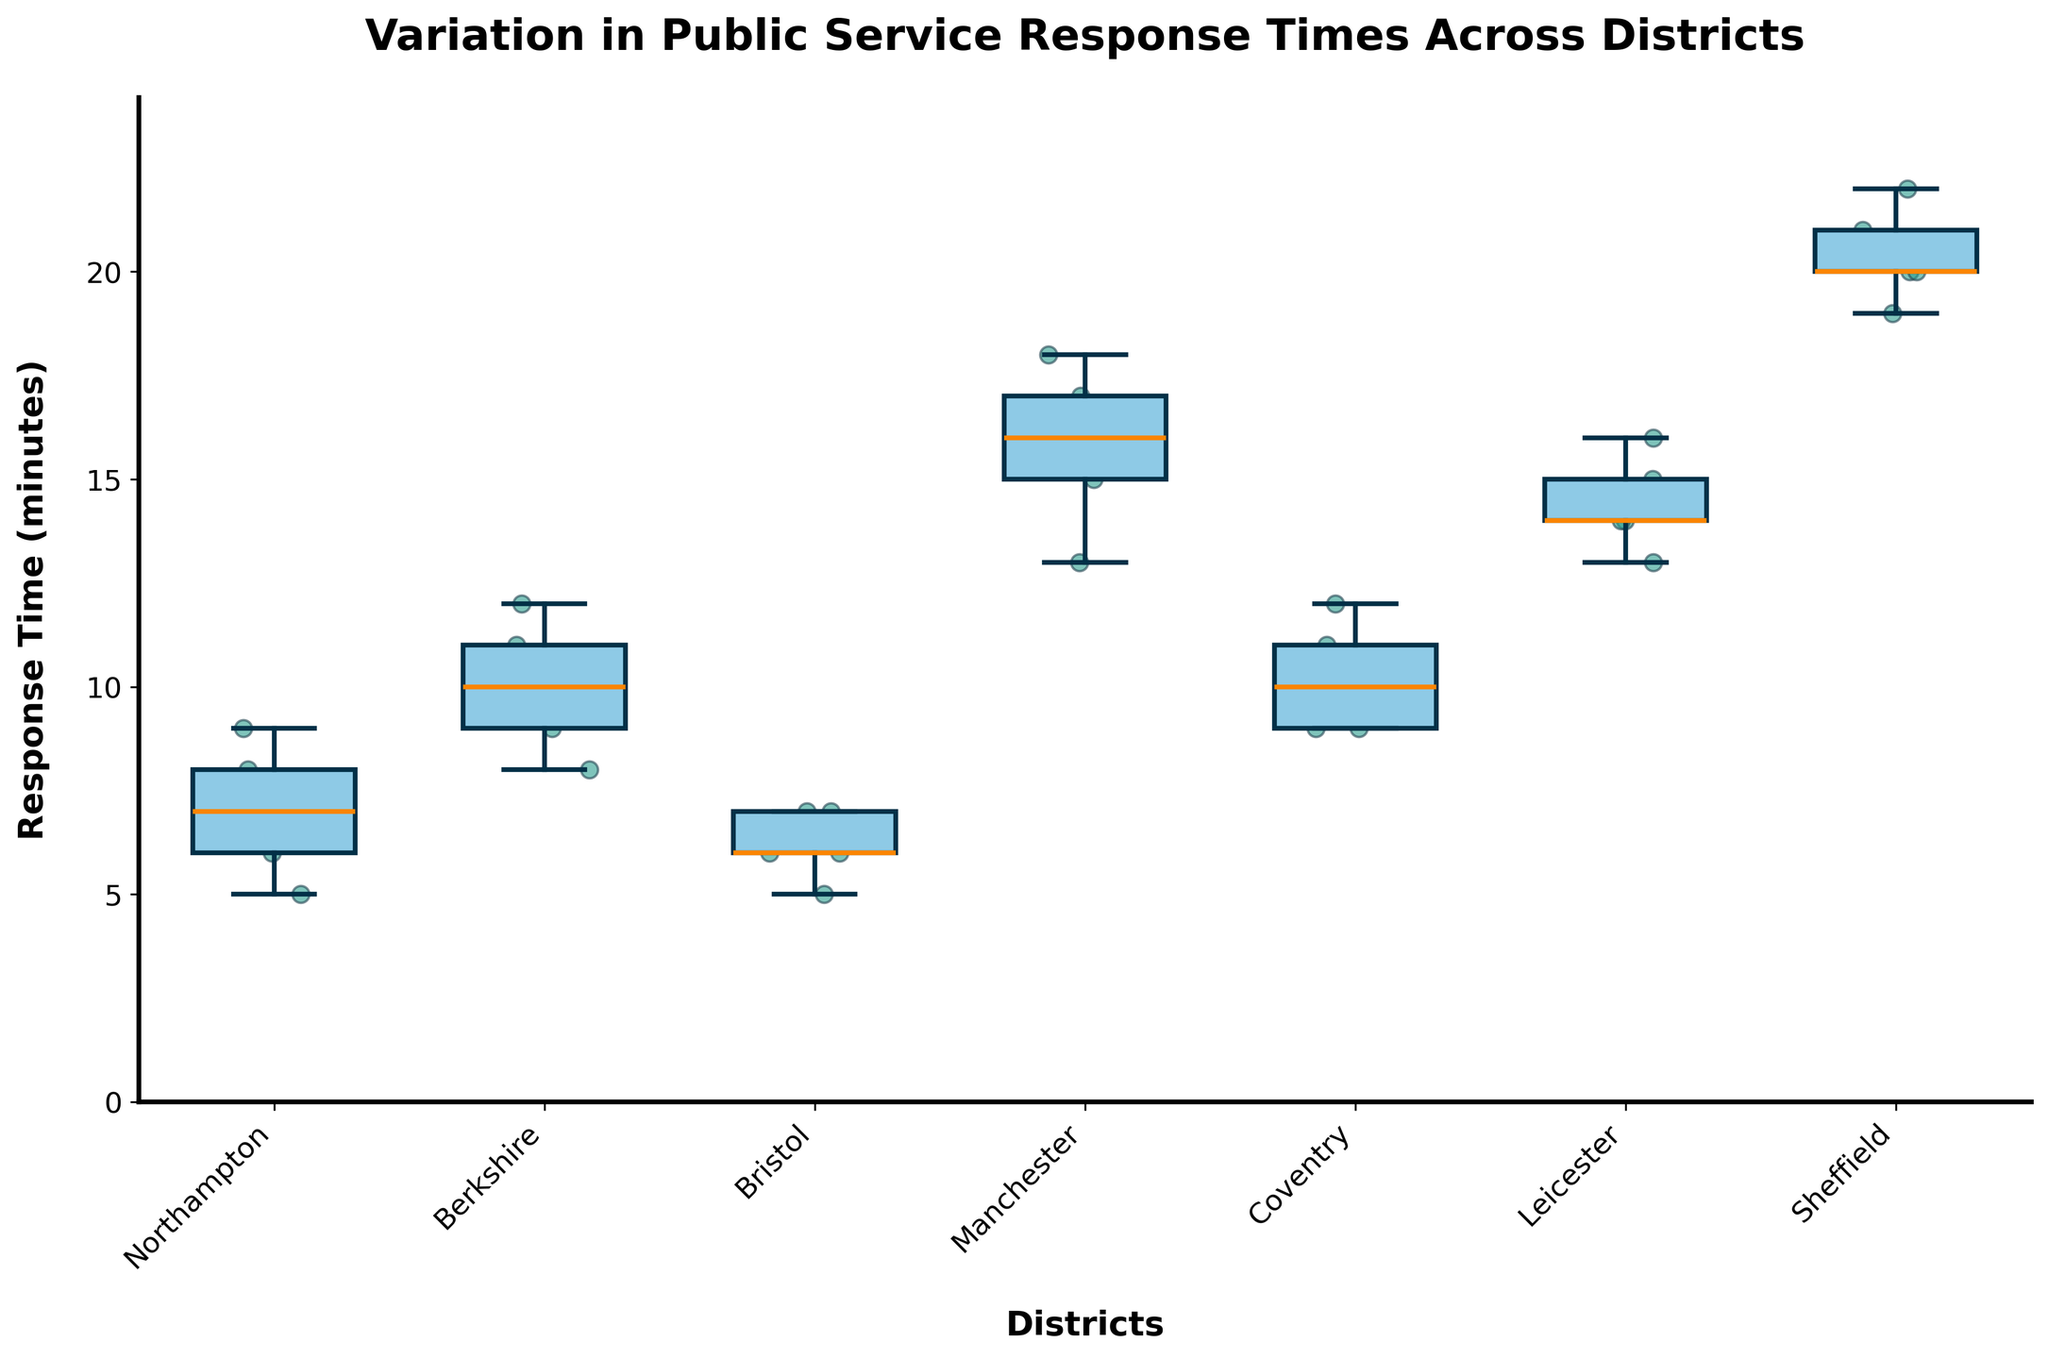What is the title of the plot? The title is usually found at the top of the plot and is generally larger and bolder than the other text. In this case, the title reads "Variation in Public Service Response Times Across Districts".
Answer: Variation in Public Service Response Times Across Districts Which district has the highest median response time? To find the highest median response time, look for the line inside the boxes (which represents the median) that is at the highest point on the y-axis. The median for Sheffield's box is at the highest position.
Answer: Sheffield What is the range of response times for Northampton? To determine the range, subtract the smallest value in the whisker from the largest value in the whisker for Northampton. The smallest value is 5 and the largest value is 9. So, the range is 9 - 5.
Answer: 4 Which district has the most consistent response times? Response time consistency can be interpreted by the interquartile range (IQR), represented by the box size. The smaller the box, the more consistent the response times. Bristol has the smallest interquartile range.
Answer: Bristol Which districts have response times that overlap completely? To determine which districts have overlapping response times, check the spread of their boxes and whiskers. Northampton and Bristol's boxes and whiskers overlap completely.
Answer: Northampton and Bristol What is the median response time for Manchester? Find the line inside the box for Manchester. The median line is at 16 minutes.
Answer: 16 How do the response times of Coventry and Leicester compare? Compare the positioning of the boxes and medians. Coventry has a lower median (~10) compared to Leicester (~14). The interquartile range of Leicester is larger than Coventry.
Answer: Coventry has lower median and smaller range Which district has the largest variability in response times? Variability can be assessed by the spread between the whiskers (range). Sheffield has the tallest box and whiskers indicating the highest variability.
Answer: Sheffield Does Bristol have any outliers in response times? Outliers are shown as individual points outside the whiskers. There are no points outside the whiskers for Bristol, indicating no outliers.
Answer: No 